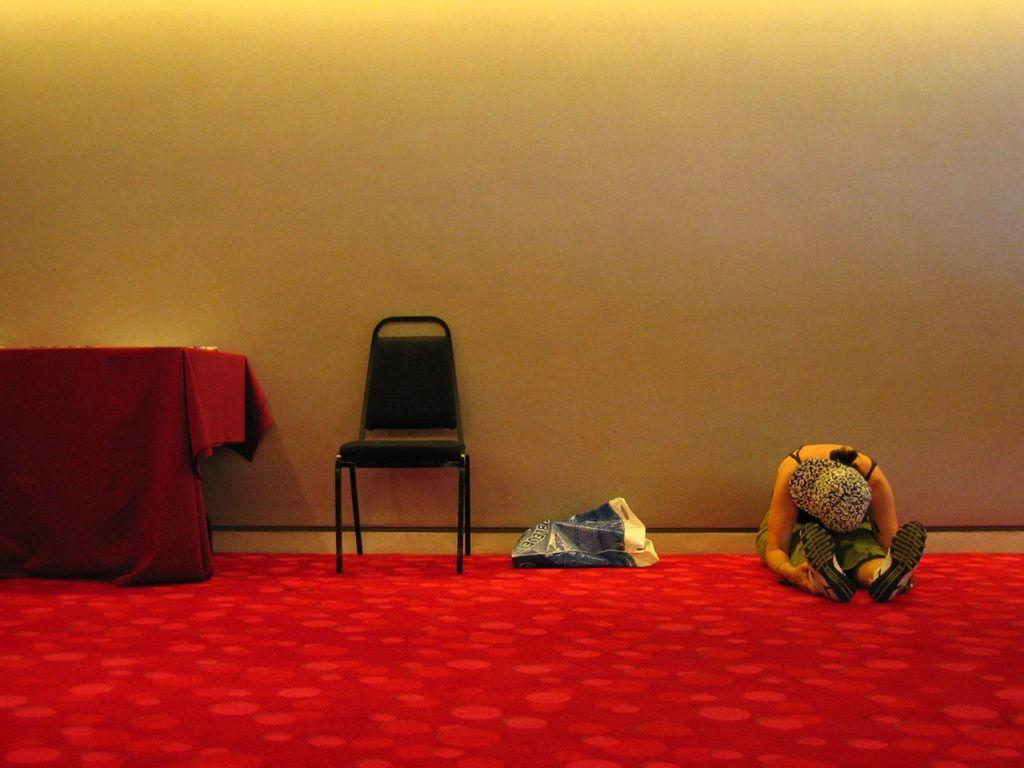Who is present in the image? There is a woman in the image. What is the woman sitting on? The woman is sitting on a red color carpet. What furniture is beside the woman? There is a chair beside the woman. What can be seen on the table in the image? There is a cloth on the table. What is visible in the background of the image? There is a wall visible in the image. What type of vegetable is the woman holding in the image? There is no vegetable present in the image; the woman is not holding anything. 